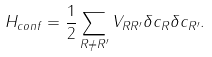<formula> <loc_0><loc_0><loc_500><loc_500>H _ { c o n f } = \frac { 1 } { 2 } \sum _ { R \neq R ^ { \prime } } V _ { R R ^ { \prime } } \delta c _ { R } \delta c _ { R ^ { \prime } } .</formula> 